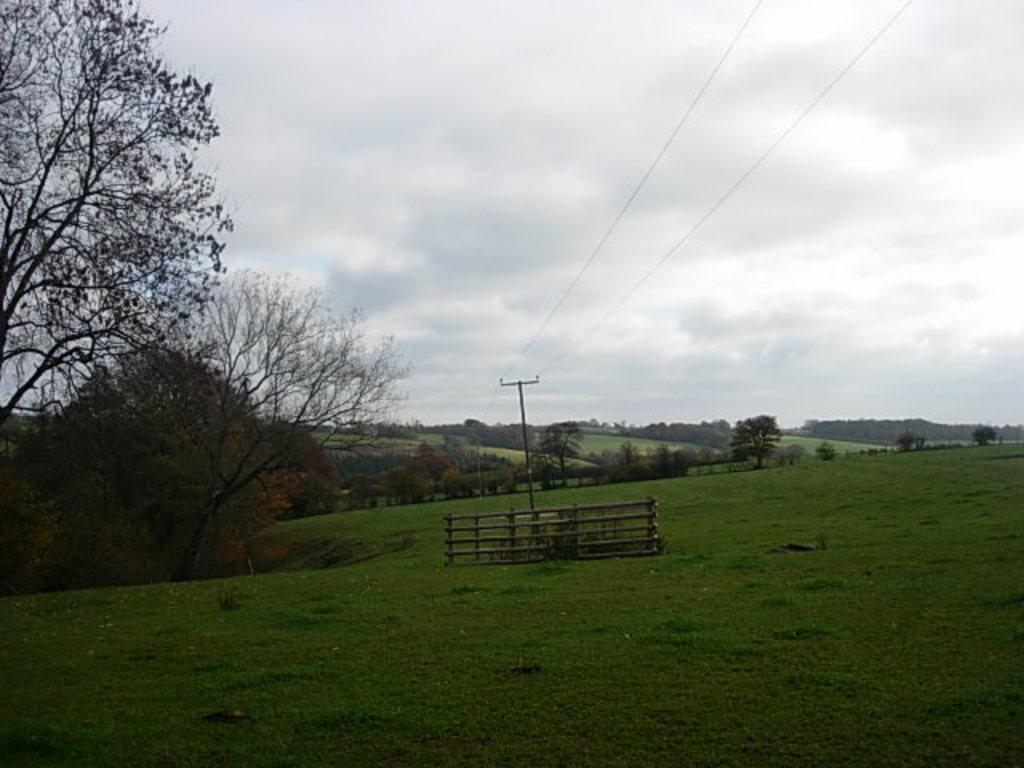What type of vegetation can be seen in the image? There is grass in the image. What structure is present in the image? There is a fence in the image. What other natural elements are visible in the image? There are trees in the image. What man-made structures can be seen in the image? There is an electric pole in the image. What else is associated with the electric pole in the image? There are electric wires in the image. How would you describe the weather in the image? The sky is cloudy in the image. Where is the potato growing in the wilderness in the image? There is no potato or wilderness present in the image. 